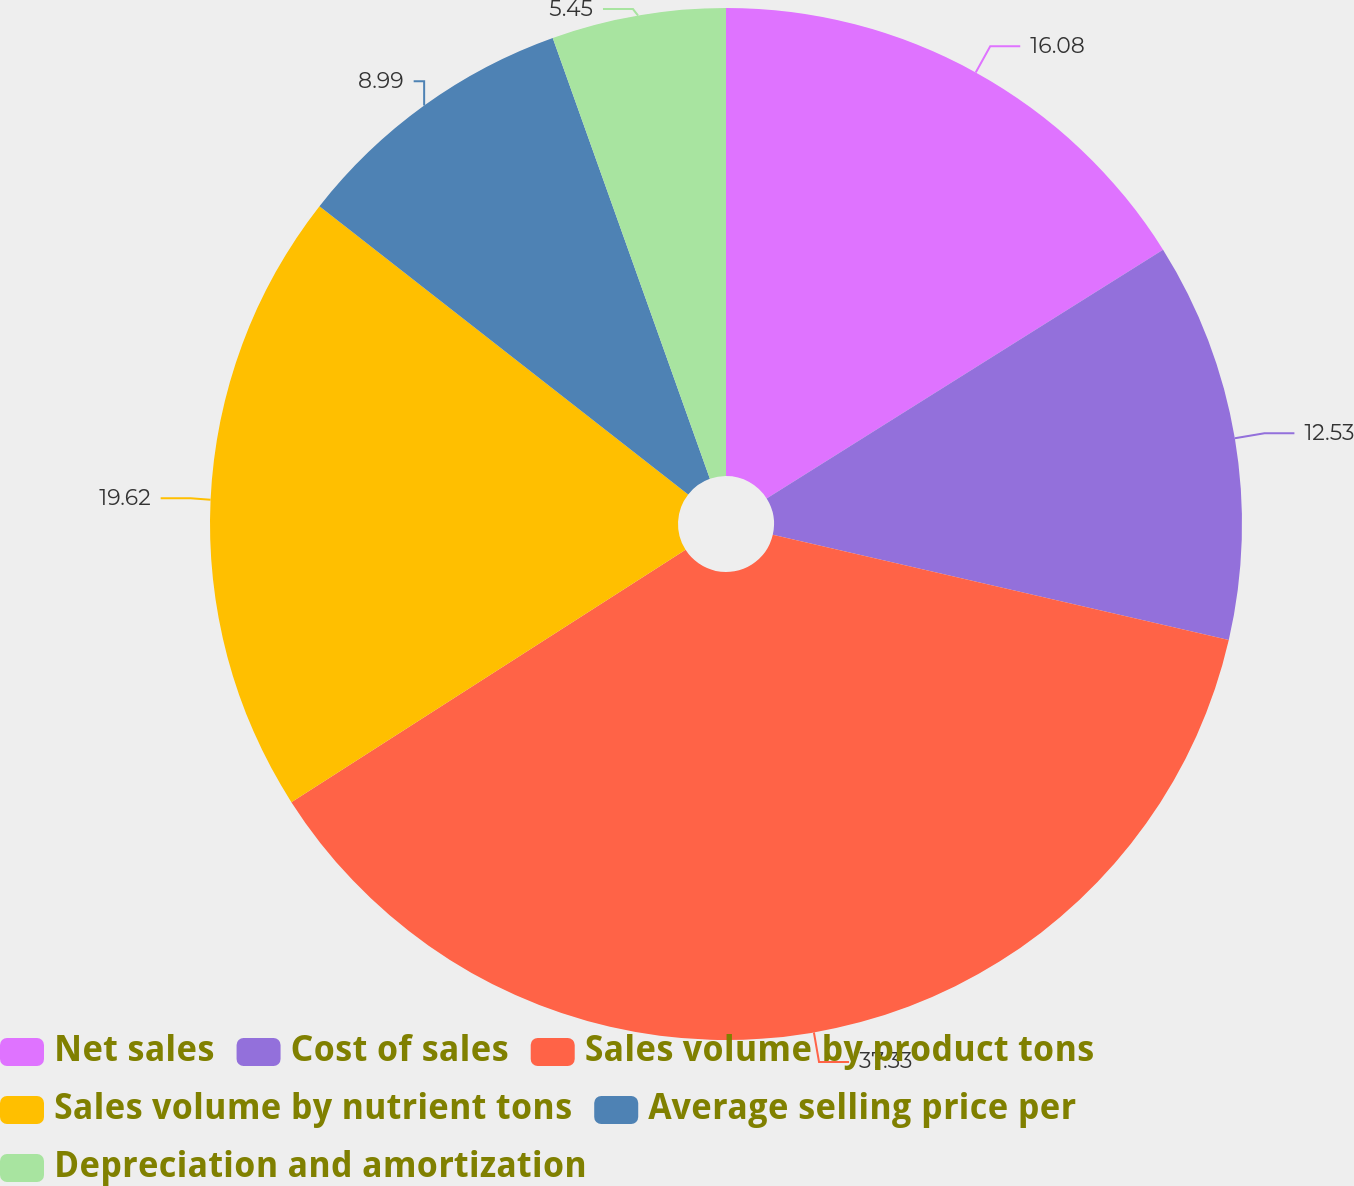Convert chart. <chart><loc_0><loc_0><loc_500><loc_500><pie_chart><fcel>Net sales<fcel>Cost of sales<fcel>Sales volume by product tons<fcel>Sales volume by nutrient tons<fcel>Average selling price per<fcel>Depreciation and amortization<nl><fcel>16.08%<fcel>12.53%<fcel>37.33%<fcel>19.62%<fcel>8.99%<fcel>5.45%<nl></chart> 